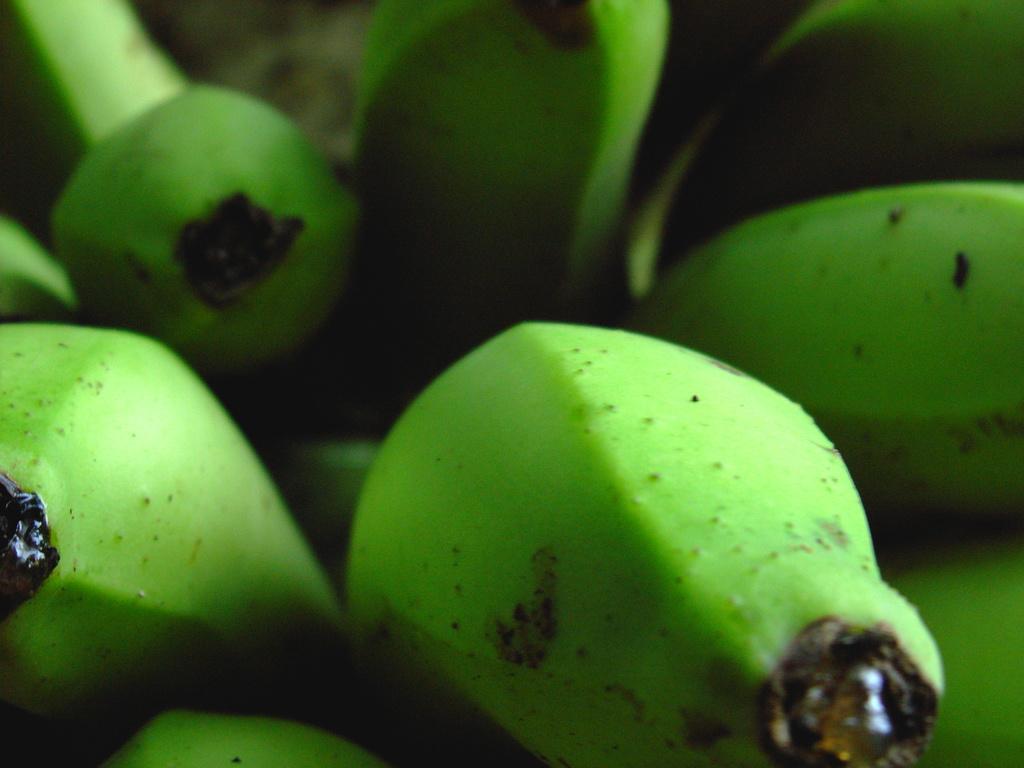Can you describe this image briefly? In this image I can see few green colour bananas. I can also see this image is little bit blurry from background. 